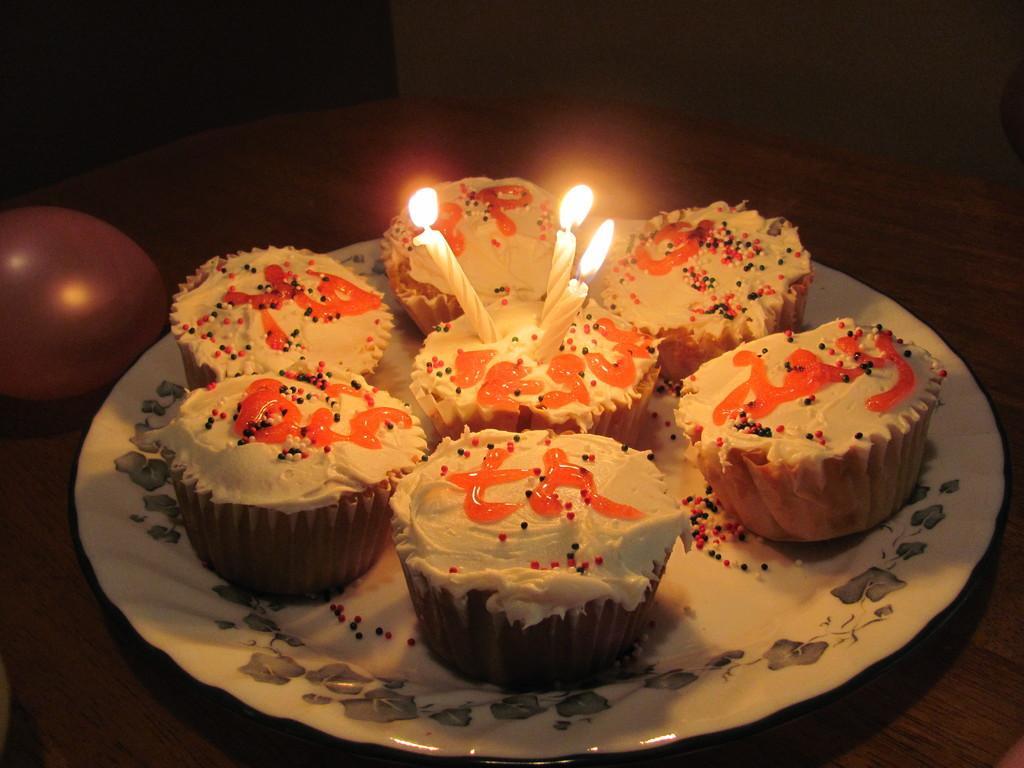Could you give a brief overview of what you see in this image? In this image we can see a balloon and a plate with some cupcakes and candles on the table. 